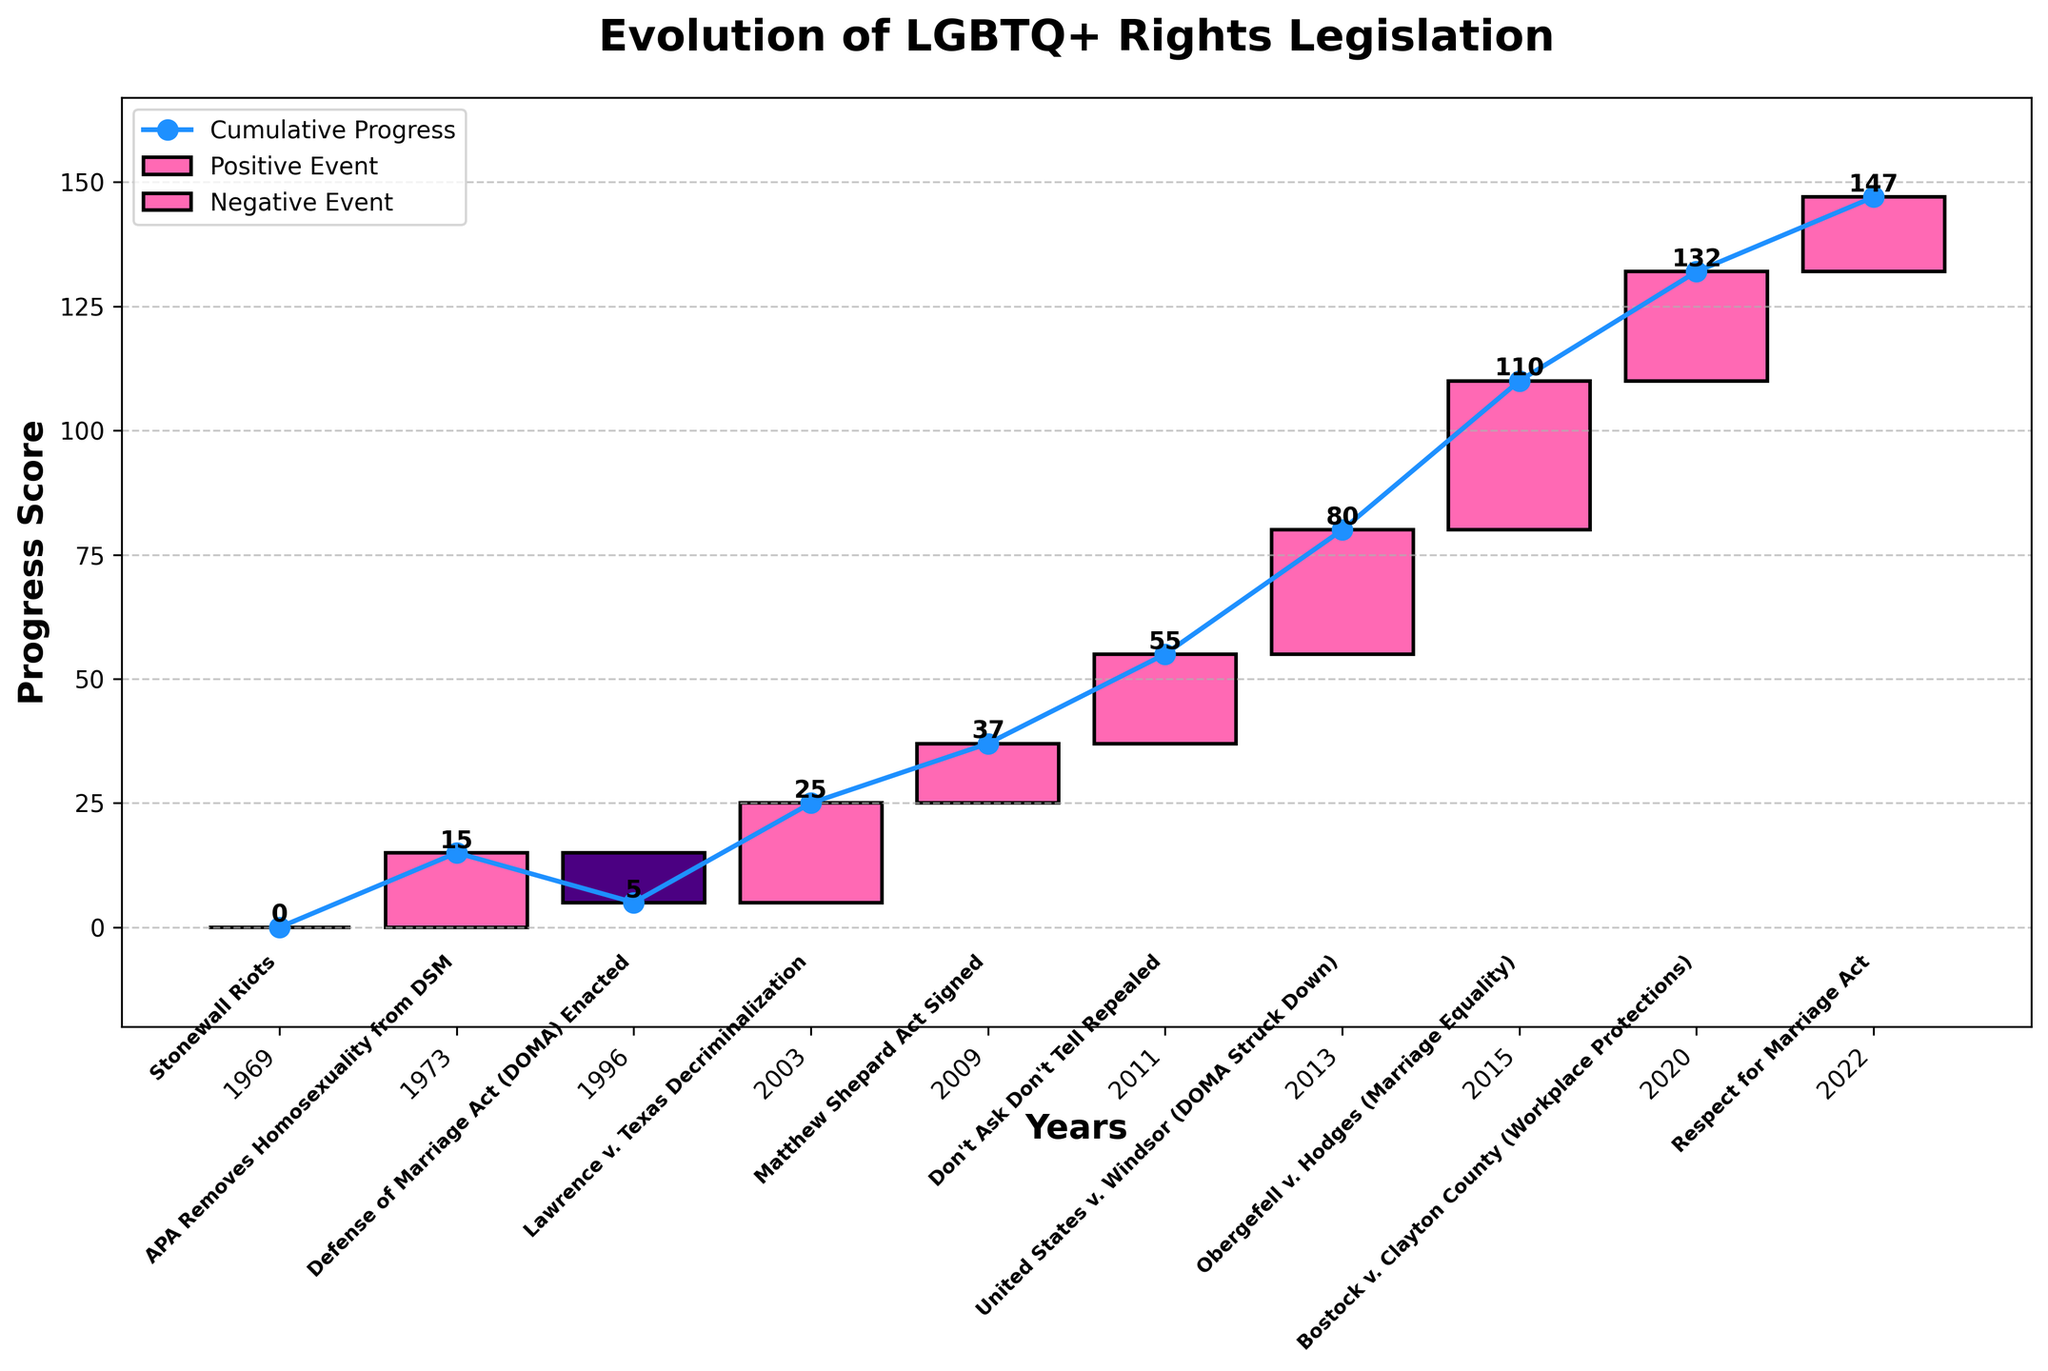What is the title of the chart? The chart title is usually placed at the top and is written in a larger, bold font for emphasis. In this case, the title is 'Evolution of LGBTQ+ Rights Legislation' as specified in the code.
Answer: Evolution of LGBTQ+ Rights Legislation In what year do we see a negative event on the chart? Negative events are represented by bars colored differently, specifically '#4B0082' (indigo). Examining the labeled bars and years, the year with this negative value is 1996, corresponding with the enactment of the Defense of Marriage Act (DOMA).
Answer: 1996 When was the 'Don't Ask, Don't Tell' policy repealed, and what was its impact value? Events are labeled along the x-axis with both year and description. The 'Don't Ask, Don't Tell' policy was repealed in 2011 and has an associated impact value of 18 as seen from the corresponding bar.
Answer: 2011, 18 What is the cumulative progress score by 2015? The cumulative progress score can be traced by summing the values sequentially up to 2015. Referencing the values, we can calculate: 0 + 15 - 10 + 20 + 12 + 18 + 25 + 30 (values up to 2015) resulting in a cumulative score of 110.
Answer: 110 Which event had the highest positive impact and in which year did it occur? The values representing impacts are plotted as bars; the one with the greatest height in the positive direction represents the highest impact. The highest value is 30, which corresponds to 'Obergefell v. Hodges (Marriage Equality)' in 2015.
Answer: Obergefell v. Hodges (Marriage Equality), 2015 What is the cumulatively lowest point on the chart? The cumulatively lowest point occurs after accounting for all positive and negative impacts in succession. Identifying from the graph or cumulative sum trend, the lowest point is after the negative value of -10 in 1996, resulting in 5 cumulative points in the same year.
Answer: 5 (occurs in 1996) How many events caused a positive shift in the progress score? Each bar on the chart represents a change. Positive shifts are denoted by bars greater than zero. By counting the bars colored via a positive color scheme, we observe 8 positive-valued events.
Answer: 8 Which year showed the largest increase in cumulative progress following a favorable legal decision? Visual inspection or calculation shows that the biggest single jump in cumulative progress is the 30-point increase following the 'Obergefell v. Hodges (Marriage Equality)' decision in 2015.
Answer: 2015 What is the average annual impact of the events listed? To find the average impact, sum all individual event impacts and divide by the number of events. Total sum is 0 + 15 - 10 + 20 + 12 + 18 + 25 + 30 + 22 + 15 = 147. With 10 events total, the average is 147/10 = 14.7
Answer: 14.7 Between which two consecutive years was there the greatest change in cumulative progress score, and what was the change? Examine the differences in cumulative values year by year. The greatest leap occurs between 2013 and 2015 (from 55 to 85 cumulative points). The change is calculated as 85 - 55 = 30.
Answer: 2013 and 2015, 30 